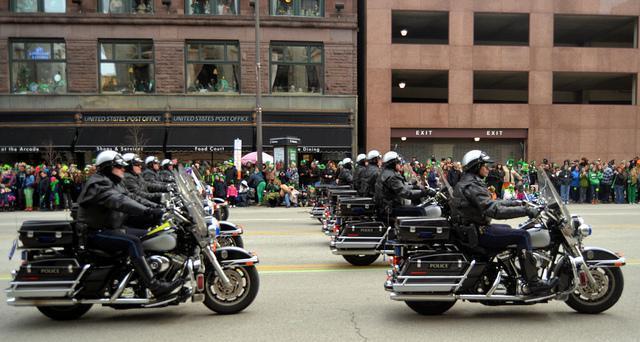How many police officers are in this scene?
Give a very brief answer. 10. How many people are there?
Give a very brief answer. 4. How many motorcycles are visible?
Give a very brief answer. 3. How many plates have a sandwich on it?
Give a very brief answer. 0. 